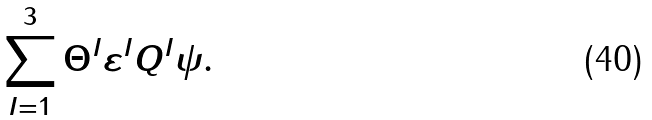<formula> <loc_0><loc_0><loc_500><loc_500>\sum _ { I = 1 } ^ { 3 } \Theta ^ { I } \varepsilon ^ { I } Q ^ { I } \psi .</formula> 